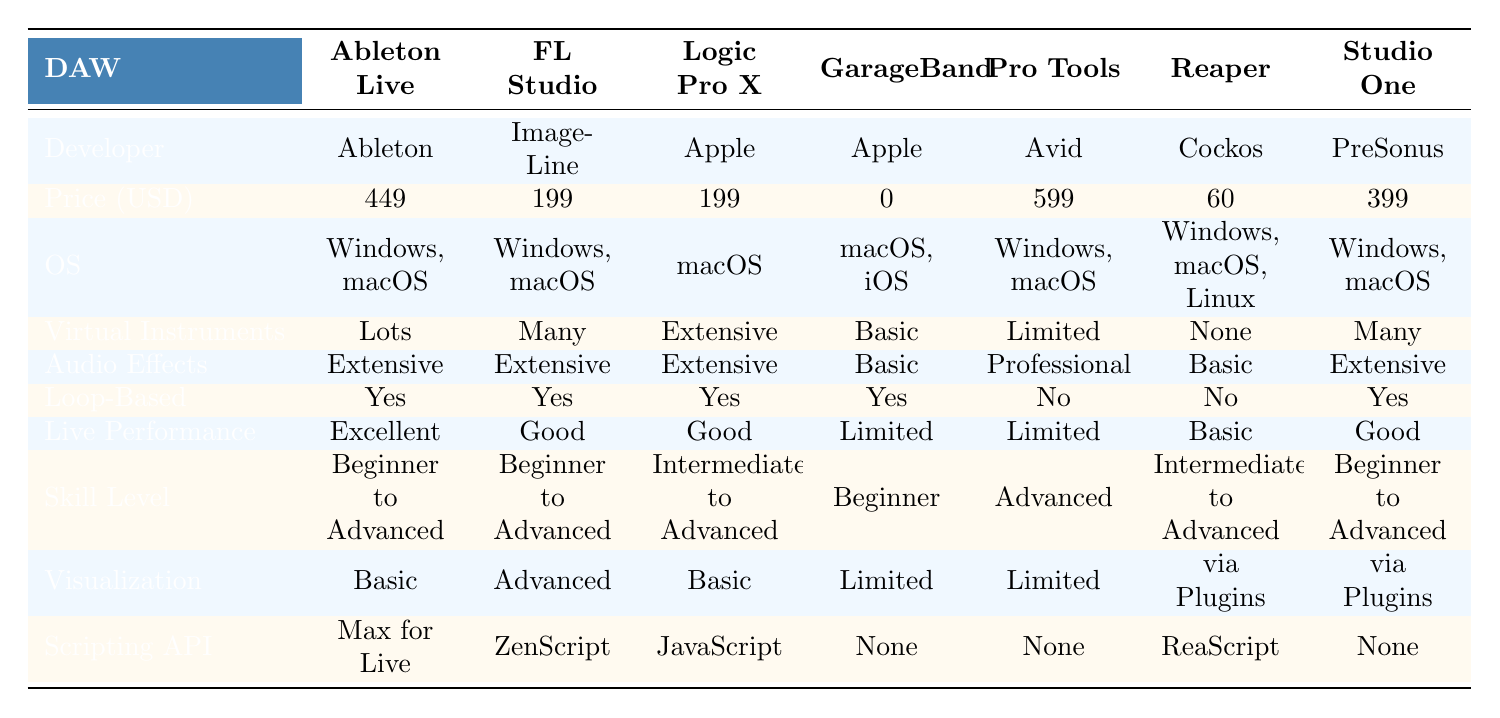What is the price of FL Studio? The table shows the price for FL Studio, which is listed under the "Price (USD)" row as 199.
Answer: 199 Which DAW has the highest price? By comparing the prices in the "Price (USD)" row, Pro Tools is listed as 599, which is the highest among all.
Answer: Pro Tools Do all DAWs have MIDI support? Looking at the "MIDI Support" row, all entries show true, indicating every DAW supports MIDI.
Answer: Yes Which DAW has the best live performance features? The "Live Performance" row indicates Ableton Live has "Excellent" features, making it the best for live performance.
Answer: Ableton Live What is the price difference between GarageBand and Reaper? GarageBand is free (0), while Reaper costs 60. The difference is 60 - 0 = 60.
Answer: 60 How many DAWs offer a free trial? The "Free Trial Available" column shows all DAWs have true, which means all 8 DAWs offer a free trial.
Answer: 8 Which DAW is suitable for beginners based on skill level? In the "Skill Level" row, GarageBand is indicated as suitable for "Beginner," and others like Live, FL Studio, and Studio One also are for "Beginner to Advanced."
Answer: GarageBand Is there a DAW that has no virtual instruments? By checking the "Virtual Instruments" row, Reaper has "None," indicating it does not include virtual instruments.
Answer: Yes What DAWs have extensive audio effects? The "Audio Effects" row shows that Ableton Live, FL Studio, Logic Pro X, and Studio One all have "Extensive" audio effects.
Answer: Ableton Live, FL Studio, Logic Pro X, Studio One Which DAW has a scripting API for customization? The "Scripting API" row indicates that Ableton Live uses "Max for Live," Reaper uses "ReaScript," and Logic Pro X uses "JavaScript."
Answer: Ableton Live, Reaper, Logic Pro X How many DAWs support loop-based workflow? The "Loop-Based" row shows 6 out of 8 DAWs support loop-based workflow, indicated as "Yes."
Answer: 6 Are there any DAWs that run only on macOS? The "OS" row indicates that Logic Pro X and GarageBand run exclusively on "macOS."
Answer: Yes 